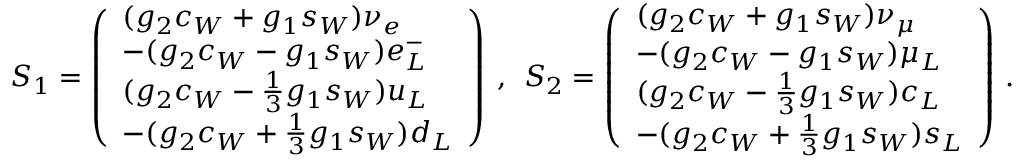<formula> <loc_0><loc_0><loc_500><loc_500>S _ { 1 } = \left ( \begin{array} { l } { { ( g _ { 2 } c _ { W } + g _ { 1 } s _ { W } ) \nu _ { e } } } \\ { { - ( g _ { 2 } c _ { W } - g _ { 1 } s _ { W } ) e _ { L } ^ { - } } } \\ { { ( g _ { 2 } c _ { W } - { \frac { 1 } { 3 } } g _ { 1 } s _ { W } ) u _ { L } } } \\ { { - ( g _ { 2 } c _ { W } + { \frac { 1 } { 3 } } g _ { 1 } s _ { W } ) d _ { L } } } \end{array} \right ) , S _ { 2 } = \left ( \begin{array} { l } { { ( g _ { 2 } c _ { W } + g _ { 1 } s _ { W } ) \nu _ { \mu } } } \\ { { - ( g _ { 2 } c _ { W } - g _ { 1 } s _ { W } ) \mu _ { L } } } \\ { { ( g _ { 2 } c _ { W } - { \frac { 1 } { 3 } } g _ { 1 } s _ { W } ) c _ { L } } } \\ { { - ( g _ { 2 } c _ { W } + { \frac { 1 } { 3 } } g _ { 1 } s _ { W } ) s _ { L } } } \end{array} \right ) \, .</formula> 